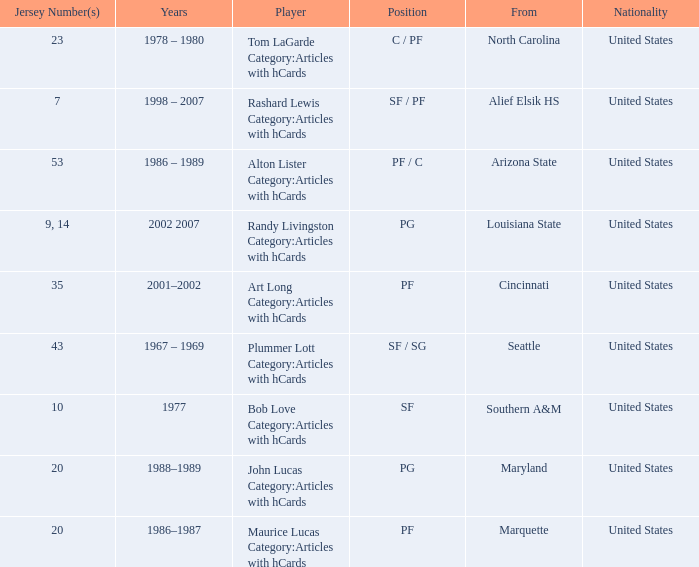Can you give me this table as a dict? {'header': ['Jersey Number(s)', 'Years', 'Player', 'Position', 'From', 'Nationality'], 'rows': [['23', '1978 – 1980', 'Tom LaGarde Category:Articles with hCards', 'C / PF', 'North Carolina', 'United States'], ['7', '1998 – 2007', 'Rashard Lewis Category:Articles with hCards', 'SF / PF', 'Alief Elsik HS', 'United States'], ['53', '1986 – 1989', 'Alton Lister Category:Articles with hCards', 'PF / C', 'Arizona State', 'United States'], ['9, 14', '2002 2007', 'Randy Livingston Category:Articles with hCards', 'PG', 'Louisiana State', 'United States'], ['35', '2001–2002', 'Art Long Category:Articles with hCards', 'PF', 'Cincinnati', 'United States'], ['43', '1967 – 1969', 'Plummer Lott Category:Articles with hCards', 'SF / SG', 'Seattle', 'United States'], ['10', '1977', 'Bob Love Category:Articles with hCards', 'SF', 'Southern A&M', 'United States'], ['20', '1988–1989', 'John Lucas Category:Articles with hCards', 'PG', 'Maryland', 'United States'], ['20', '1986–1987', 'Maurice Lucas Category:Articles with hCards', 'PF', 'Marquette', 'United States']]} Bob Love Category:Articles with hCards is from where? Southern A&M. 